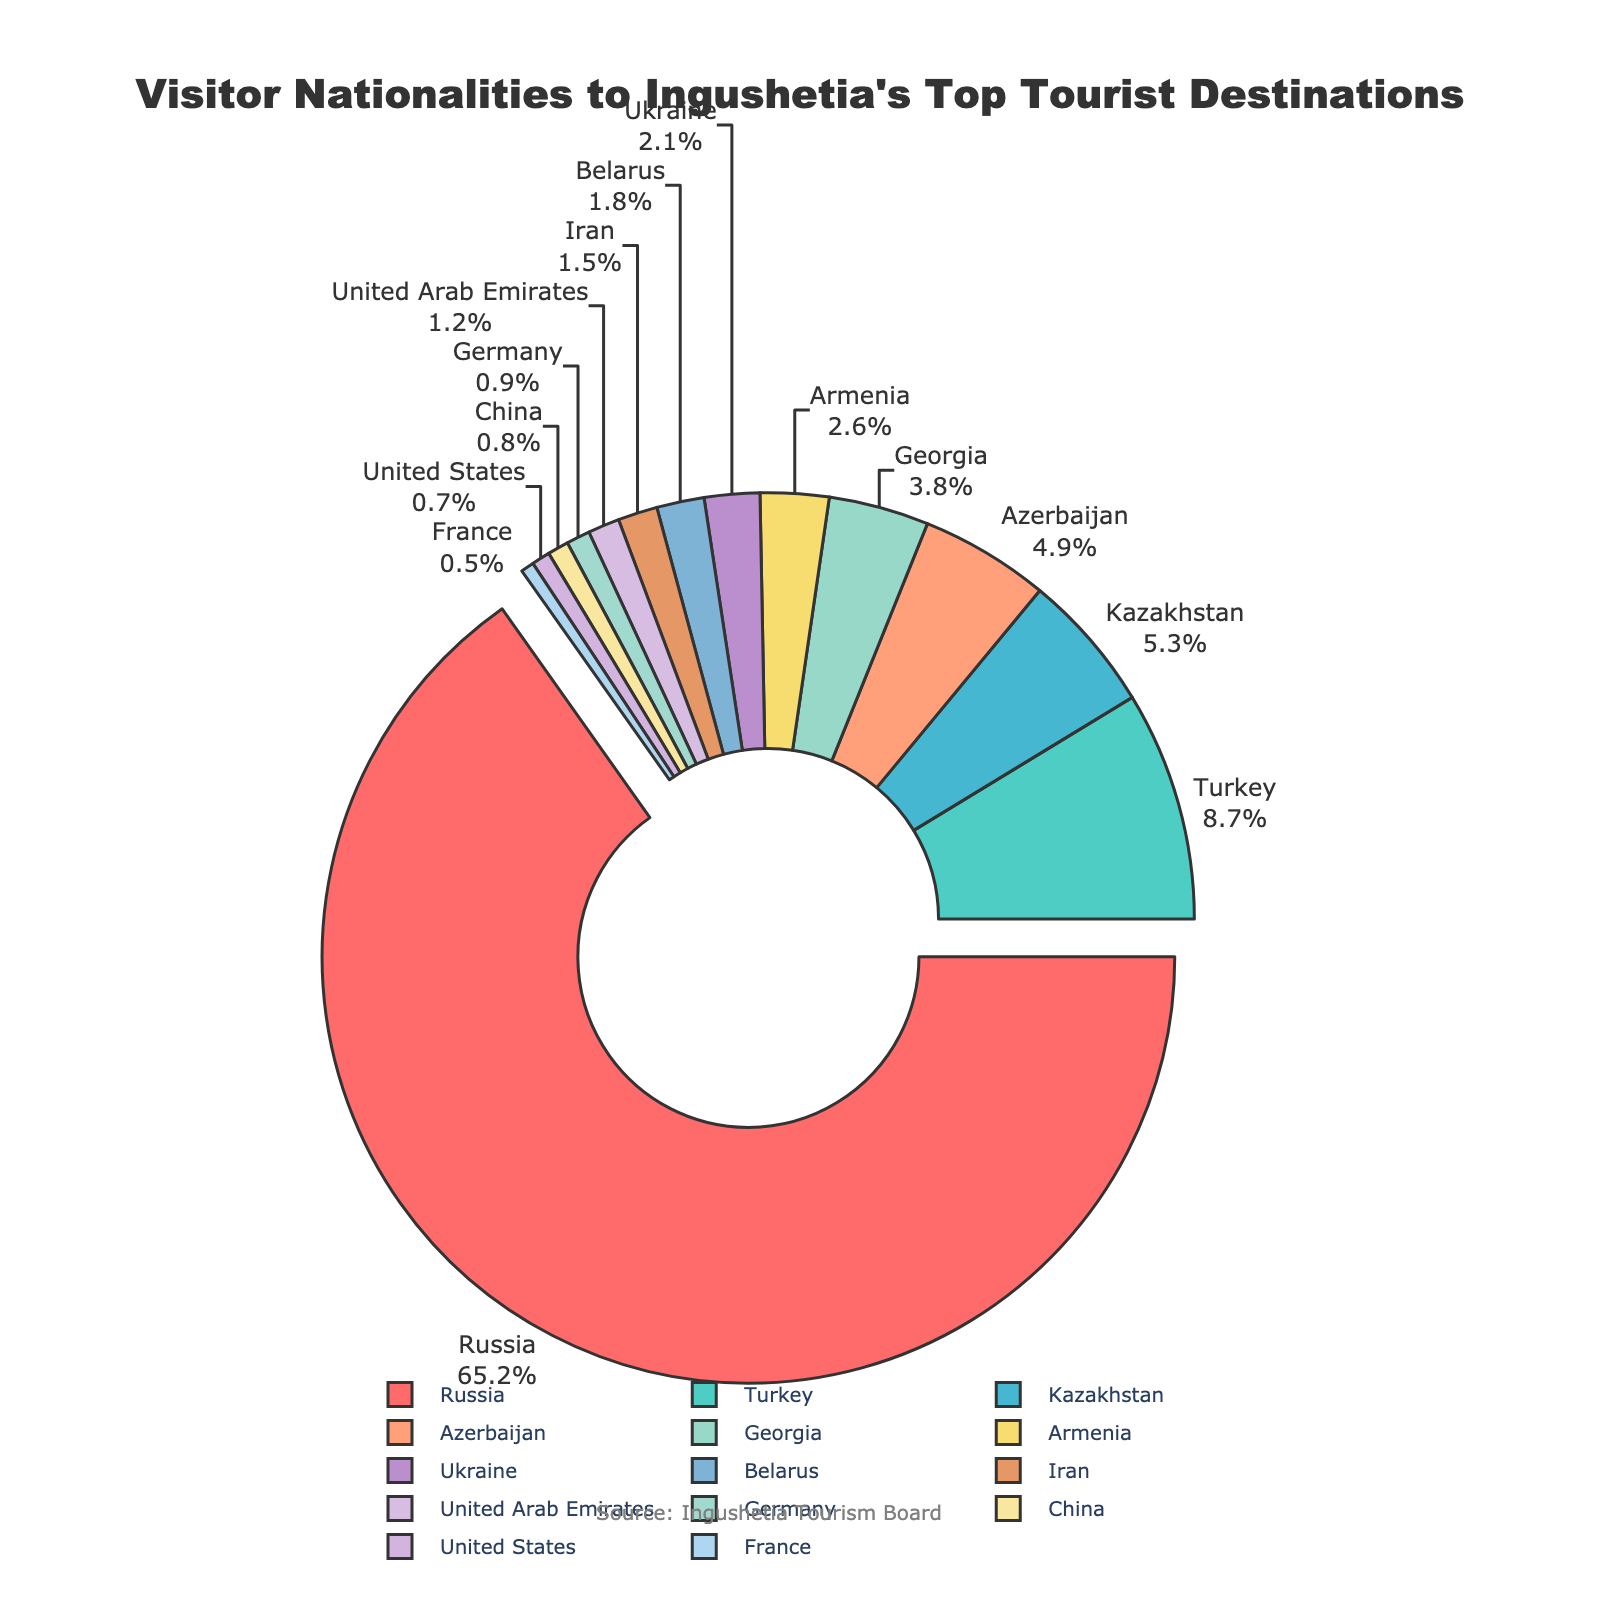Which country represents the largest portion of visitors? The figure shows that the largest portion is labeled with "Russia" and makes up the largest pie segment.
Answer: Russia Which three countries make up the smallest portion of visitors combined? The smallest segments are labeled with "France", "United States", and "China". Summing their percentages gives 0.5 + 0.7 + 0.8.
Answer: France, United States, China How much larger is the percentage of visitors from Russia compared to Turkey? The percentage of visitors from Russia is 65.2% and from Turkey is 8.7%. The difference is calculated as 65.2 - 8.7.
Answer: 56.5% How many countries have visitor percentages above 5%? The figure shows the percentages next to the labels, and the only countries above 5% are Russia and Turkey.
Answer: 2 Which countries have visitor percentages between 2% and 3%? The figure shows that Armenia (2.6%) and Ukraine (2.1%) fall between 2% and 3%.
Answer: Armenia, Ukraine What is the sum of the visitor percentages for Belarus and Germany? According to the figure, Belarus has 1.8% and Germany has 0.9%, and their sum is 1.8 + 0.9.
Answer: 2.7% Does Iran have a higher percentage of visitors than the United Arab Emirates? Comparing the segments, Iran has 1.5% and the United Arab Emirates has 1.2%.
Answer: Yes Is the total percentage of visitors from countries other than Russia less than 40%? The remaining percentage is calculated as 100% - 65.2% (Russia's percentage).
Answer: No Which two countries have the closest visitor percentages to each other? The percentages closest to each other are Azerbaijan (4.9%) and Georgia (3.8%) with a difference of 1.1%.
Answer: Azerbaijan, Georgia 